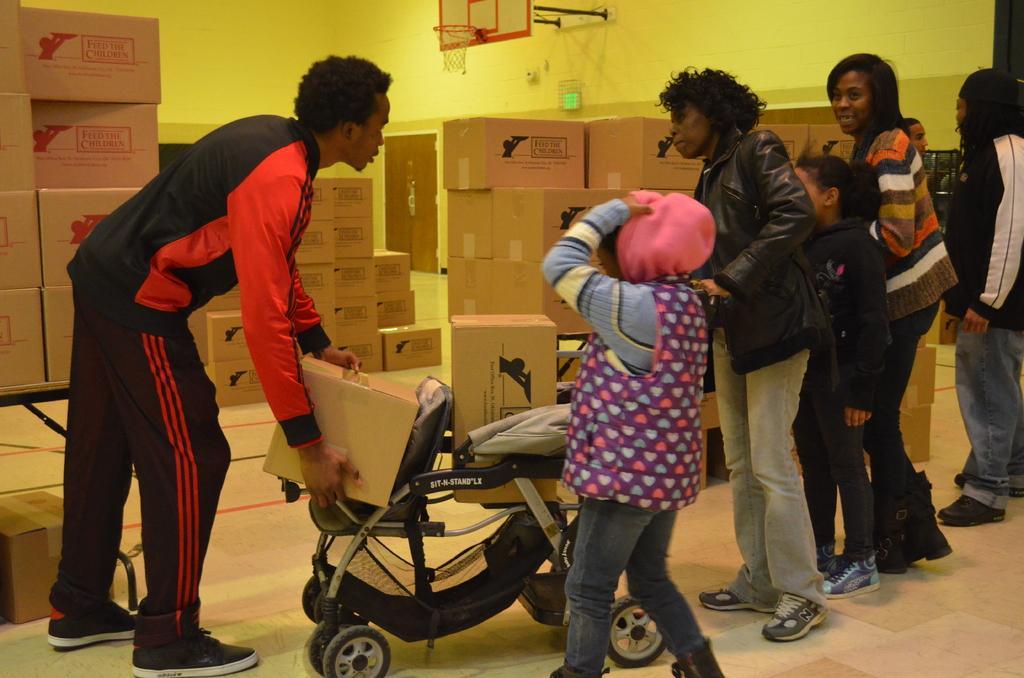Describe this image in one or two sentences. In this image I can see number of persons are standing on the floor and I can see a stroller which is black and grey in color on the ground. In the background I can see number of cardboard boxes which are brown in color, the yellow colored wall, the basket ball goal post and the door which is brown in color. 